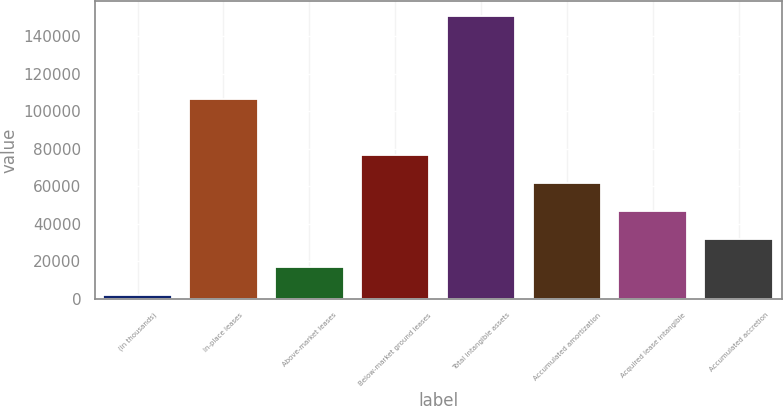<chart> <loc_0><loc_0><loc_500><loc_500><bar_chart><fcel>(in thousands)<fcel>In-place leases<fcel>Above-market leases<fcel>Below-market ground leases<fcel>Total intangible assets<fcel>Accumulated amortization<fcel>Acquired lease intangible<fcel>Accumulated accretion<nl><fcel>2015<fcel>106318<fcel>16915.4<fcel>76517<fcel>151019<fcel>61616.6<fcel>46716.2<fcel>31815.8<nl></chart> 